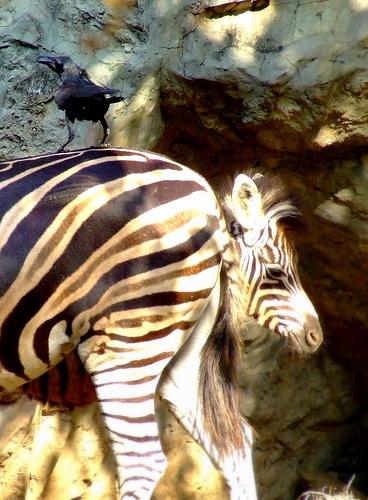What gender are these zebras?
Concise answer only. Female. How many animals are in the picture?
Be succinct. 3. Is the zebra bothered by the bird riding her?
Short answer required. No. 